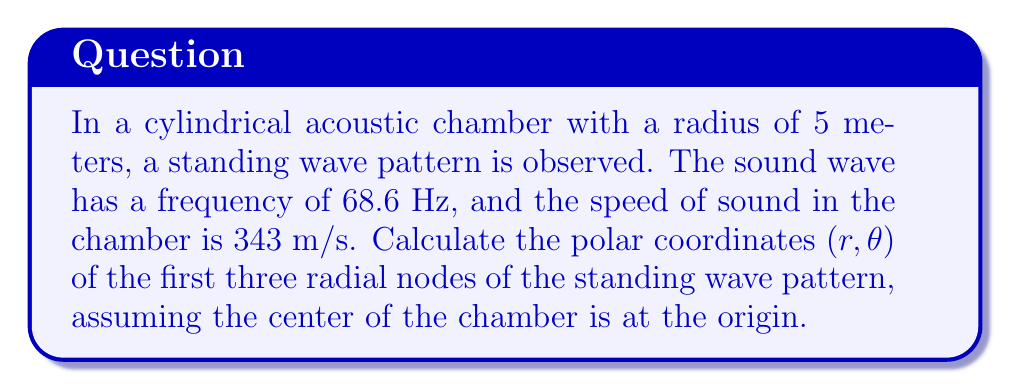Can you answer this question? To solve this problem, we need to follow these steps:

1) First, calculate the wavelength $\lambda$ of the sound wave:
   $$\lambda = \frac{v}{f} = \frac{343 \text{ m/s}}{68.6 \text{ Hz}} = 5 \text{ m}$$

2) In a cylindrical chamber, the radial component of the standing wave pattern is described by the Bessel function of the first kind, $J_0(kr)$, where $k = \frac{2\pi}{\lambda}$ is the wave number.

3) The radial nodes occur where $J_0(kr) = 0$. The first few zeros of $J_0$ occur at:
   $$kr = 2.4048, 5.5201, 8.6537, ...$$

4) We can find $r$ for each node using:
   $$r = \frac{\lambda}{2\pi} \cdot \text{zero of } J_0$$

5) For the first node:
   $$r_1 = \frac{5}{2\pi} \cdot 2.4048 = 1.91 \text{ m}$$

6) For the second node:
   $$r_2 = \frac{5}{2\pi} \cdot 5.5201 = 4.39 \text{ m}$$

7) For the third node:
   $$r_3 = \frac{5}{2\pi} \cdot 8.6537 = 6.88 \text{ m}$$

8) Note that the third node is outside the chamber radius, so it won't be observed in this setup.

9) The angle $\theta$ can be any value from 0 to $2\pi$ for each node, as the pattern is radially symmetric.

Therefore, the polar coordinates of the observable nodes are:
- First node: $(1.91, \theta)$, where $0 \leq \theta < 2\pi$
- Second node: $(4.39, \theta)$, where $0 \leq \theta < 2\pi$
Answer: The polar coordinates of the first two radial nodes are:
1. $(1.91 \text{ m}, \theta)$
2. $(4.39 \text{ m}, \theta)$
where $0 \leq \theta < 2\pi$ for both nodes. 